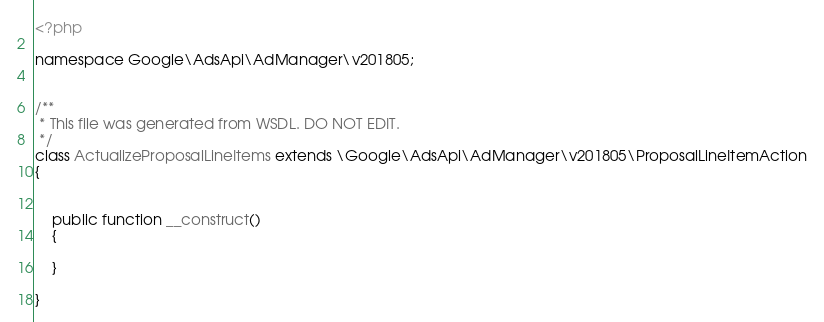Convert code to text. <code><loc_0><loc_0><loc_500><loc_500><_PHP_><?php

namespace Google\AdsApi\AdManager\v201805;


/**
 * This file was generated from WSDL. DO NOT EDIT.
 */
class ActualizeProposalLineItems extends \Google\AdsApi\AdManager\v201805\ProposalLineItemAction
{

    
    public function __construct()
    {
    
    }

}
</code> 